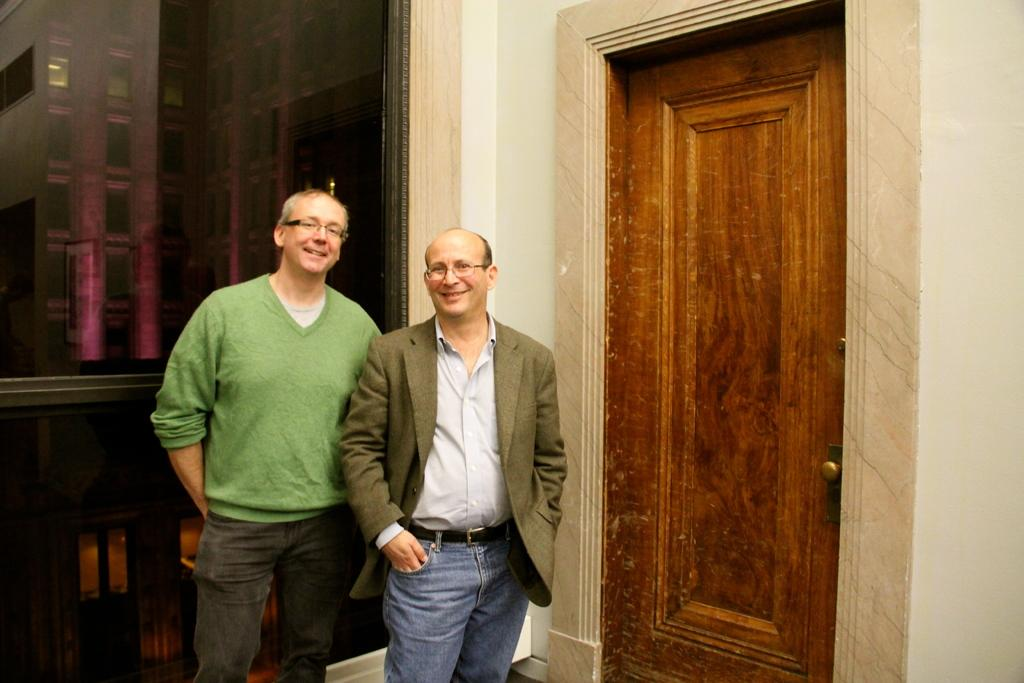What are the main subjects in the center of the image? There are persons standing in the center of the image. What surface are the persons standing on? The persons are standing on the floor. What can be seen on the right side of the image? There is a door on the right side of the image. What is visible in the background of the image? There is a window and a building visible in the background of the image. What type of coal is being used by the persons in the image? There is no coal present in the image; the persons are simply standing. 